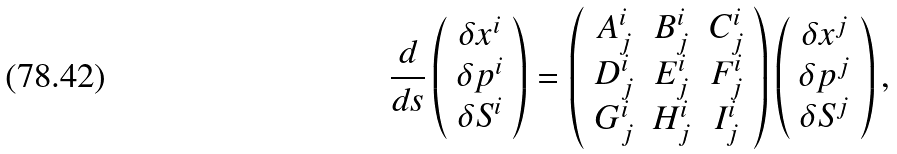Convert formula to latex. <formula><loc_0><loc_0><loc_500><loc_500>\frac { d } { d s } \left ( \begin{array} { c } \delta x ^ { i } \\ \delta p ^ { i } \\ \delta S ^ { i } \end{array} \right ) = \left ( \begin{array} { c c c } A _ { j } ^ { i } & B _ { j } ^ { i } & C _ { j } ^ { i } \\ D _ { j } ^ { i } & E _ { j } ^ { i } & F _ { j } ^ { i } \\ G _ { j } ^ { i } & H _ { j } ^ { i } & I _ { j } ^ { i } \end{array} \right ) \left ( \begin{array} { c } \delta x ^ { j } \\ \delta p ^ { j } \\ \delta S ^ { j } \end{array} \right ) ,</formula> 